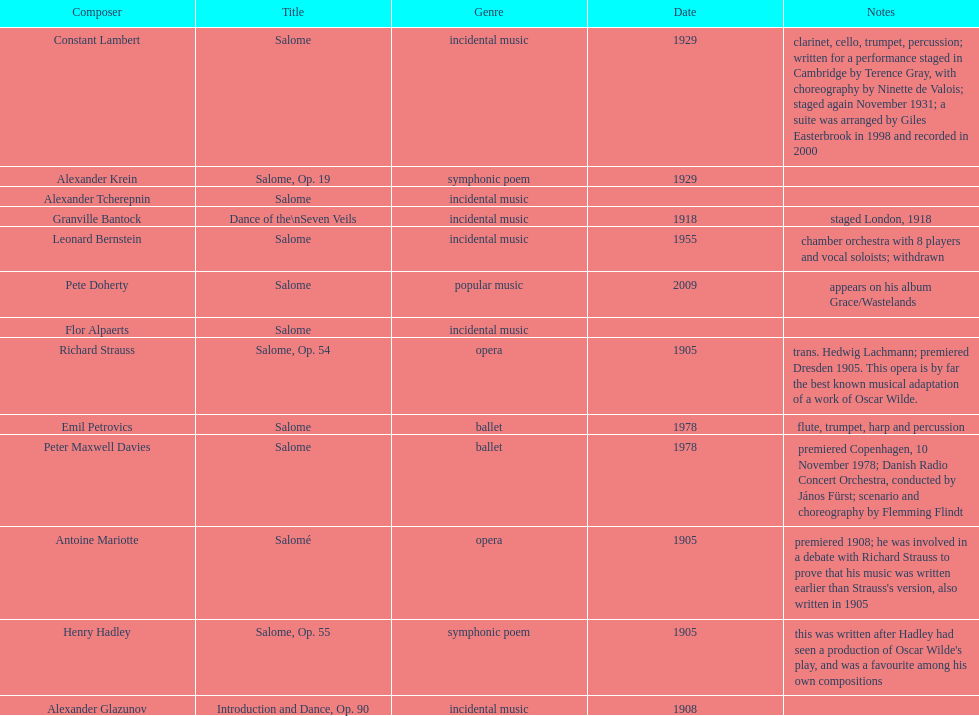Help me parse the entirety of this table. {'header': ['Composer', 'Title', 'Genre', 'Date', 'Notes'], 'rows': [['Constant Lambert', 'Salome', 'incidental music', '1929', 'clarinet, cello, trumpet, percussion; written for a performance staged in Cambridge by Terence Gray, with choreography by Ninette de Valois; staged again November 1931; a suite was arranged by Giles Easterbrook in 1998 and recorded in 2000'], ['Alexander Krein', 'Salome, Op. 19', 'symphonic poem', '1929', ''], ['Alexander\xa0Tcherepnin', 'Salome', 'incidental music', '', ''], ['Granville Bantock', 'Dance of the\\nSeven Veils', 'incidental music', '1918', 'staged London, 1918'], ['Leonard Bernstein', 'Salome', 'incidental music', '1955', 'chamber orchestra with 8 players and vocal soloists; withdrawn'], ['Pete Doherty', 'Salome', 'popular music', '2009', 'appears on his album Grace/Wastelands'], ['Flor Alpaerts', 'Salome', 'incidental\xa0music', '', ''], ['Richard Strauss', 'Salome, Op. 54', 'opera', '1905', 'trans. Hedwig Lachmann; premiered Dresden 1905. This opera is by far the best known musical adaptation of a work of Oscar Wilde.'], ['Emil Petrovics', 'Salome', 'ballet', '1978', 'flute, trumpet, harp and percussion'], ['Peter\xa0Maxwell\xa0Davies', 'Salome', 'ballet', '1978', 'premiered Copenhagen, 10 November 1978; Danish Radio Concert Orchestra, conducted by János Fürst; scenario and choreography by Flemming Flindt'], ['Antoine Mariotte', 'Salomé', 'opera', '1905', "premiered 1908; he was involved in a debate with Richard Strauss to prove that his music was written earlier than Strauss's version, also written in 1905"], ['Henry Hadley', 'Salome, Op. 55', 'symphonic poem', '1905', "this was written after Hadley had seen a production of Oscar Wilde's play, and was a favourite among his own compositions"], ['Alexander Glazunov', 'Introduction and Dance, Op. 90', 'incidental music', '1908', '']]} What creation was authored following henry hadley's viewing of an oscar wilde stage production? Salome, Op. 55. 